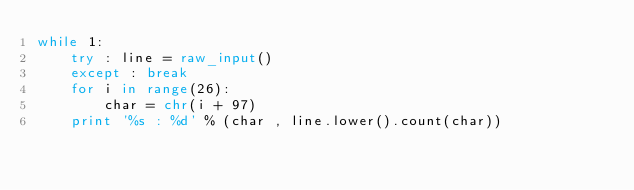<code> <loc_0><loc_0><loc_500><loc_500><_Python_>while 1:
    try : line = raw_input()
    except : break
    for i in range(26):
        char = chr(i + 97)
    print '%s : %d' % (char , line.lower().count(char))</code> 